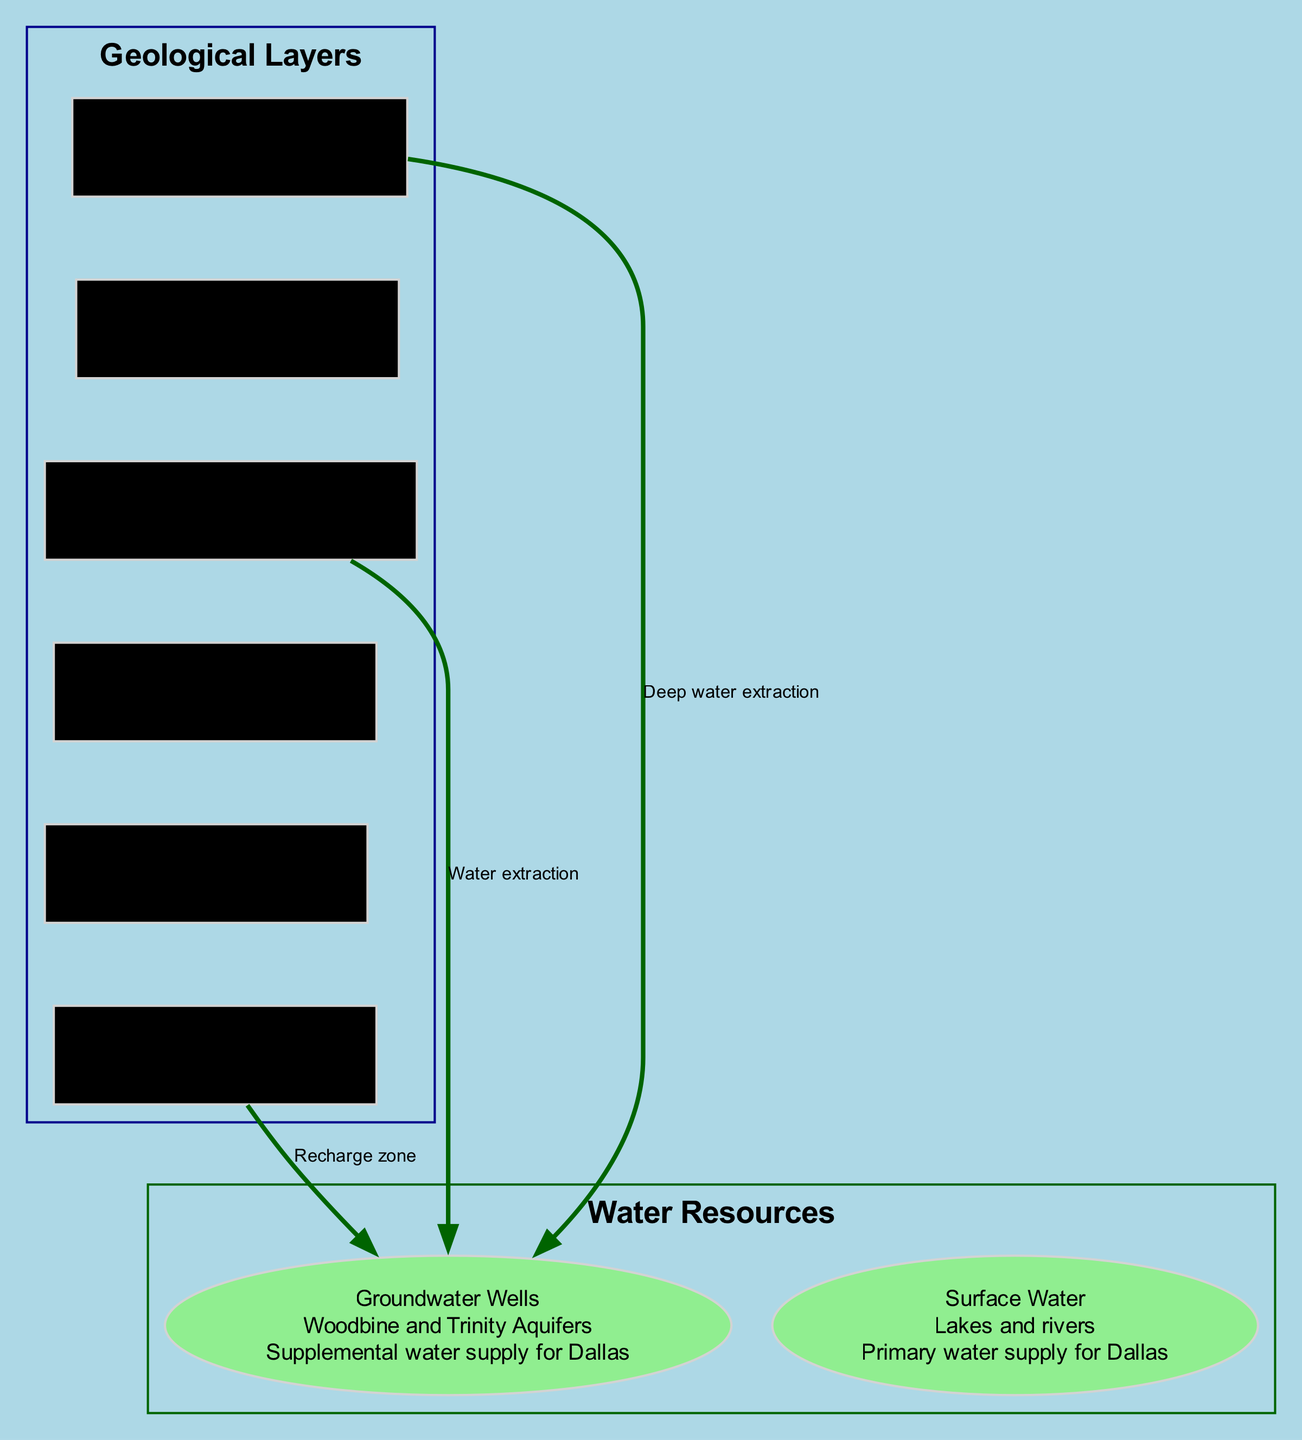What is the depth range of the Woodbine Aquifer? Referring to the diagram, the Woodbine Aquifer is located between 900 and 1500 feet.
Answer: 900-1500 ft What type of geological layer is found at a depth of 600-900 feet? The Eagle Ford Shale is the layer found within the specified depth range of 600-900 feet.
Answer: Eagle Ford Shale How many primary water resources are depicted in the diagram? The diagram shows two primary water resources: Groundwater Wells and Surface Water.
Answer: 2 What connection describes the relationship between the Woodbine Aquifer and Groundwater Wells? The description indicates that the relationship is defined as "Water extraction" from the Woodbine Aquifer to Groundwater Wells.
Answer: Water extraction Which geological layer directly replenishes the groundwater wells? The connection labeled as "Recharge zone" indicates that the Surface Layer acts directly to replenish the groundwater wells.
Answer: Surface Layer What is the primary use of Surface Water according to the diagram? The diagram states that Surface Water is used as the "Primary water supply for Dallas."
Answer: Primary water supply for Dallas At what depth does the Trinity Aquifer start? The Trinity Aquifer starts at a depth of 2000 feet.
Answer: 2000 ft What describes the nature of the Eagle Ford Shale layer? The diagram highlights that the Eagle Ford Shale is classified as an "Impermeable layer."
Answer: Impermeable layer Which aquifer is indicated as a major water source for Dallas? The Woodbine Aquifer is identified as the "Major water source for Dallas area" in the diagram.
Answer: Woodbine Aquifer 